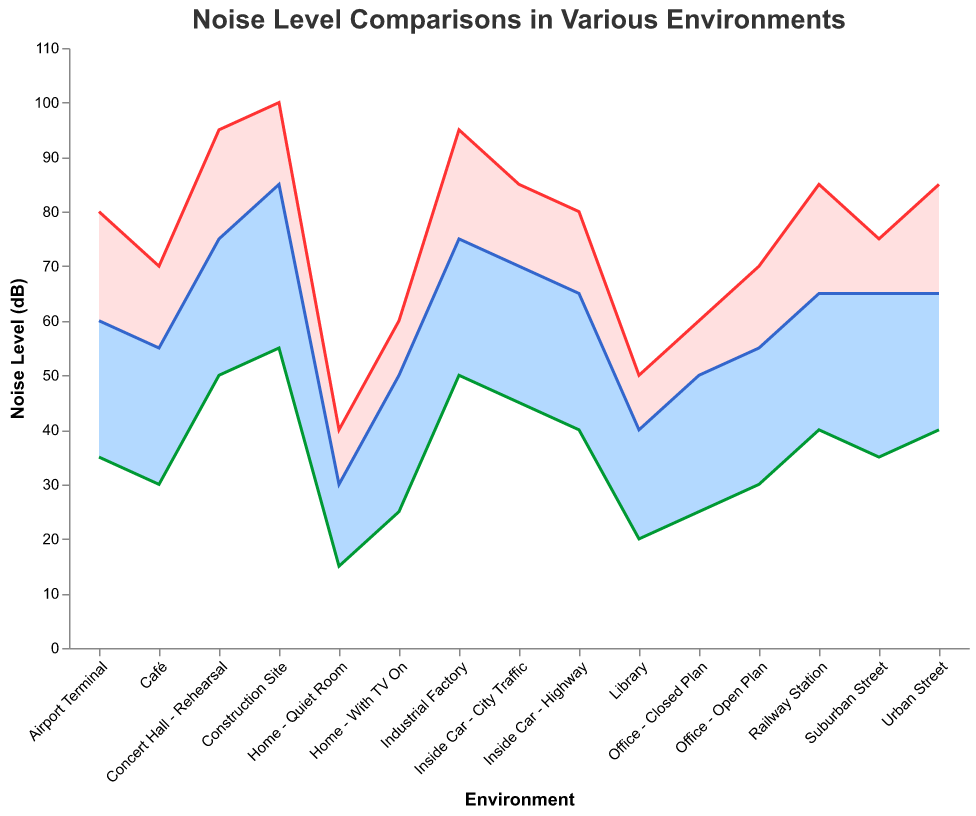What is the title of the figure? The title is located at the top of the figure. It provides a brief description of what the figure represents.
Answer: Noise Level Comparisons in Various Environments Which environment has the highest noise level without canceling? To determine this, locate the environment with the highest value on the y-axis under "Noise Without Canceling (dB)" category.
Answer: Construction Site How much does active canceling reduce the noise in a suburban street compared to no canceling? Identify the noise levels for "Suburban Street" under both "Noise Without Canceling (dB)" and "Noise With Active Canceling (dB)." Then, subtract the latter from the former: 75 - 35.
Answer: 40 dB Which environment shows the least effective noise reduction with passive canceling? Compare the difference between "Noise Without Canceling (dB)" and "Noise With Passive Canceling (dB)" across all environments, and find the smallest difference. For "Suburban Street" and "Home - With TV On," the reduction is 10 dB each.
Answer: Suburban Street or Home - With TV On What is the median noise level with active canceling across all environments? List all the "Noise With Active Canceling (dB)" values, and find the median by arranging them in ascending order and identifying the middle value(s). Values: 15, 20, 25, 25, 30, 30, 35, 35, 40, 40, 40, 45, 50, 50, 55. Median value is the 8th value in an ascending sorted list.
Answer: 35 dB How does the noise level with passive canceling at an airport terminal compare to an office open plan? Locate the noise levels for "Airport Terminal" and "Office - Open Plan" under "Noise With Passive Canceling (dB)" and compare the two values: 60 vs. 55.
Answer: Airport Terminal is 5 dB higher What is the average noise reduction achieved with active canceling in all environments? Sum up all noise reductions by active canceling and divide by the number of environments. Calculate for each environment, sum them, and find the average. (70-30) + (60-25) + (85-40) + (75-35) + (40-15) + (60-25) + (80-35) + (85-40) + (95-50) + (50-20) + (70-30) + (85-45) + (80-40) + (100-55) + (95-50) = 795. Then divide by 15 (number of environments).
Answer: 53 dB Which environment shows the greatest difference between passive canceling and active canceling noise levels? Subtract "Noise With Active Canceling (dB)" from "Noise With Passive Canceling (dB)" for each environment and identify the maximum difference.
Answer: Construction Site Is the noise level with active canceling in a railway station higher or lower than an inside car - highway? Compare the "Noise With Active Canceling (dB)" values for "Railway Station" (40) and "Inside Car - Highway" (40).
Answer: Equal 